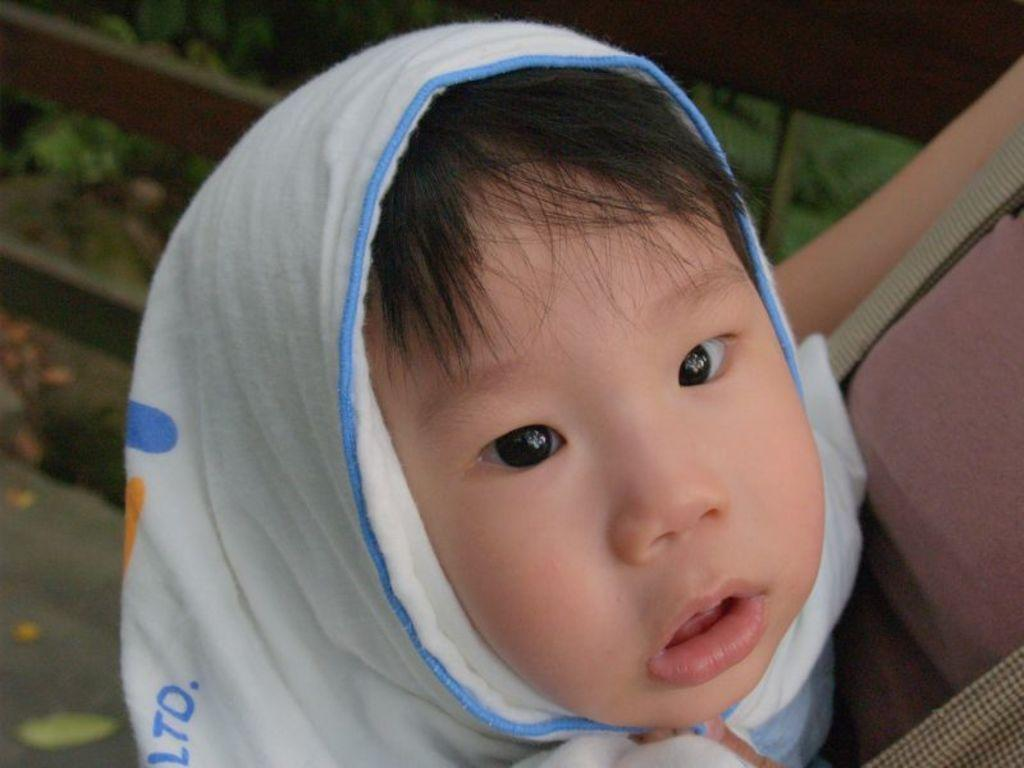Who is the main subject in the image? There is a girl in the image. What is the girl wearing around her neck? The girl is wearing a white scarf. What object is beside the girl? There is a bag beside the girl. Where is the girl sitting in the image? The girl is sitting on a bench. What can be seen in the top left corner of the image? There is a plant in the top left corner of the image. What type of glass is the girl holding in the image? There is no glass present in the image; the girl is wearing a white scarf and sitting on a bench. 